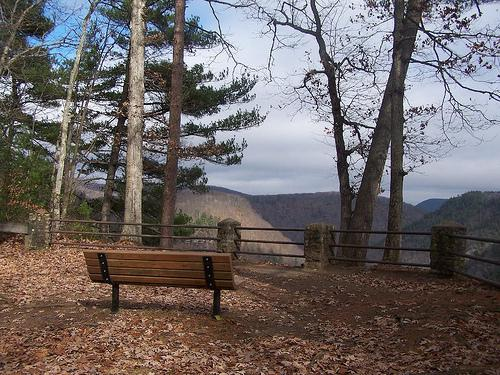Question: where is this shot?
Choices:
A. Grand Tetons.
B. Great Smokey Mountains.
C. Mountain view spot.
D. West Virginia.
Answer with the letter. Answer: C Question: how many people are in the shot?
Choices:
A. 1.
B. 0.
C. 2.
D. 3.
Answer with the letter. Answer: B 